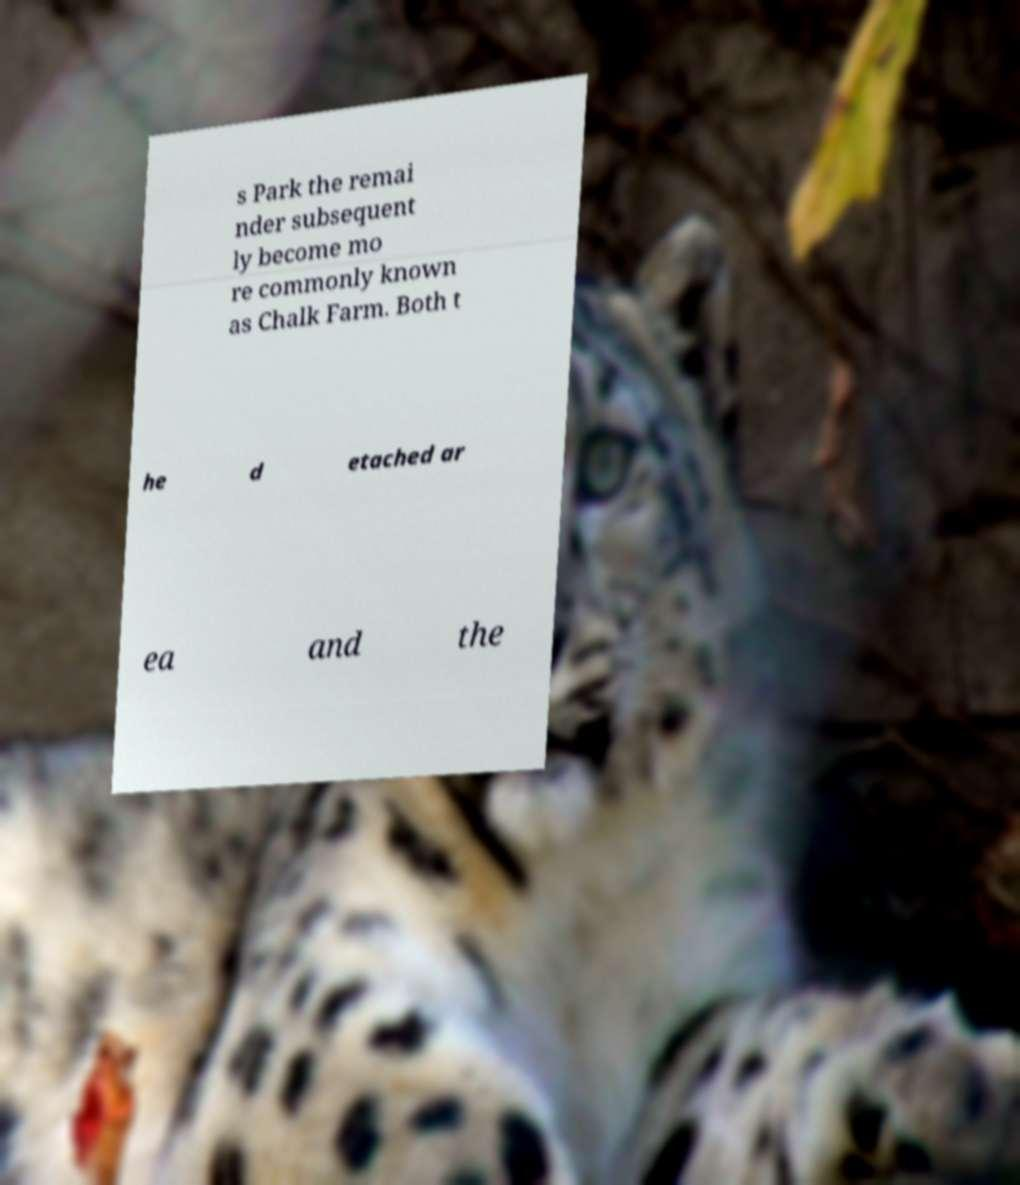Can you accurately transcribe the text from the provided image for me? s Park the remai nder subsequent ly become mo re commonly known as Chalk Farm. Both t he d etached ar ea and the 